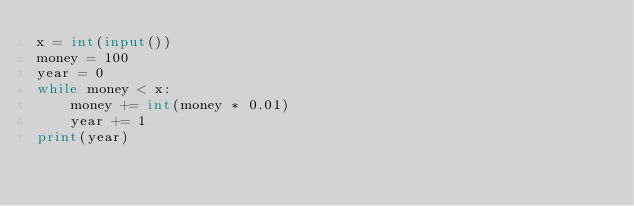Convert code to text. <code><loc_0><loc_0><loc_500><loc_500><_Python_>x = int(input())
money = 100
year = 0
while money < x:
    money += int(money * 0.01)
    year += 1
print(year)</code> 